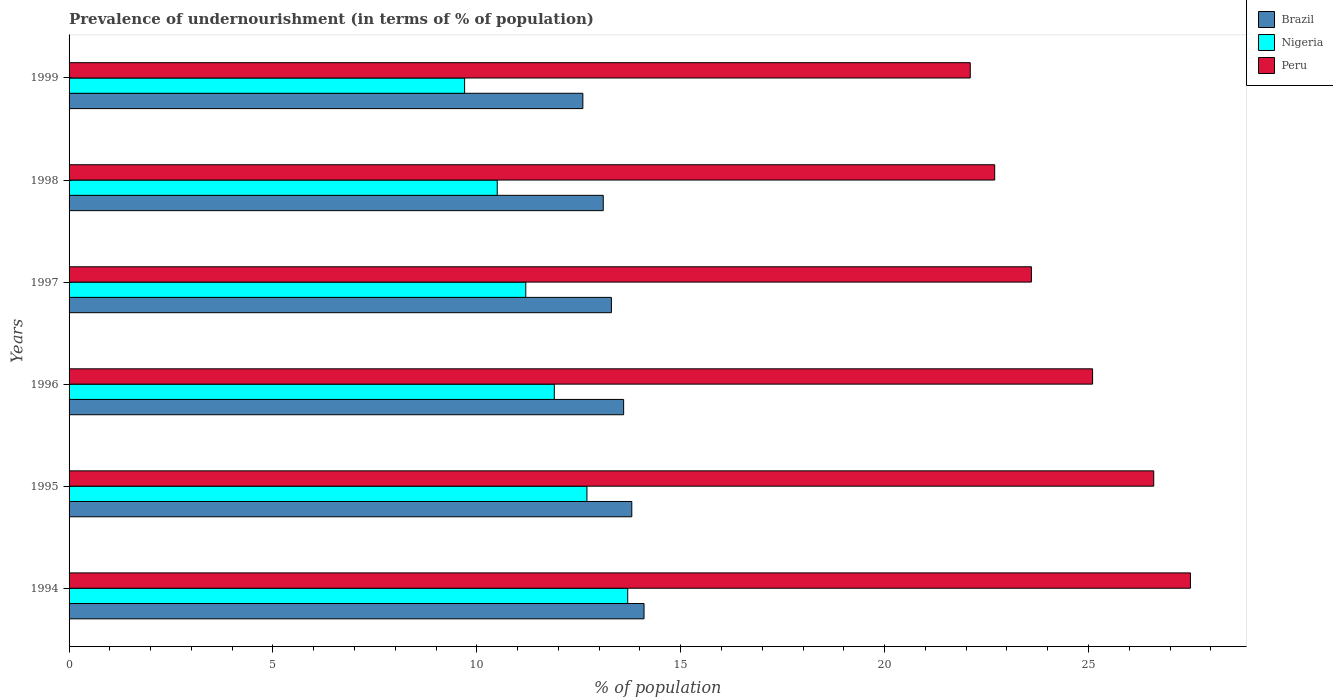How many bars are there on the 1st tick from the top?
Your answer should be very brief. 3. How many bars are there on the 4th tick from the bottom?
Your answer should be very brief. 3. In how many cases, is the number of bars for a given year not equal to the number of legend labels?
Make the answer very short. 0. What is the percentage of undernourished population in Peru in 1997?
Provide a short and direct response. 23.6. Across all years, what is the maximum percentage of undernourished population in Brazil?
Make the answer very short. 14.1. In which year was the percentage of undernourished population in Nigeria maximum?
Your response must be concise. 1994. What is the total percentage of undernourished population in Brazil in the graph?
Offer a very short reply. 80.5. What is the difference between the percentage of undernourished population in Peru in 1995 and that in 1996?
Give a very brief answer. 1.5. What is the difference between the percentage of undernourished population in Brazil in 1995 and the percentage of undernourished population in Nigeria in 1998?
Give a very brief answer. 3.3. What is the average percentage of undernourished population in Nigeria per year?
Your answer should be very brief. 11.62. In the year 1994, what is the difference between the percentage of undernourished population in Brazil and percentage of undernourished population in Nigeria?
Make the answer very short. 0.4. In how many years, is the percentage of undernourished population in Peru greater than 10 %?
Keep it short and to the point. 6. What is the ratio of the percentage of undernourished population in Peru in 1995 to that in 1998?
Provide a succinct answer. 1.17. Is the difference between the percentage of undernourished population in Brazil in 1995 and 1996 greater than the difference between the percentage of undernourished population in Nigeria in 1995 and 1996?
Ensure brevity in your answer.  No. What is the difference between the highest and the second highest percentage of undernourished population in Brazil?
Give a very brief answer. 0.3. Is the sum of the percentage of undernourished population in Nigeria in 1997 and 1998 greater than the maximum percentage of undernourished population in Peru across all years?
Provide a short and direct response. No. What does the 2nd bar from the top in 1999 represents?
Ensure brevity in your answer.  Nigeria. What does the 1st bar from the bottom in 1995 represents?
Provide a short and direct response. Brazil. How many bars are there?
Your answer should be compact. 18. Are all the bars in the graph horizontal?
Your response must be concise. Yes. What is the difference between two consecutive major ticks on the X-axis?
Offer a very short reply. 5. Does the graph contain any zero values?
Ensure brevity in your answer.  No. Does the graph contain grids?
Provide a short and direct response. No. How are the legend labels stacked?
Your answer should be very brief. Vertical. What is the title of the graph?
Your answer should be compact. Prevalence of undernourishment (in terms of % of population). Does "Nepal" appear as one of the legend labels in the graph?
Your answer should be very brief. No. What is the label or title of the X-axis?
Your answer should be very brief. % of population. What is the label or title of the Y-axis?
Make the answer very short. Years. What is the % of population of Brazil in 1994?
Your answer should be very brief. 14.1. What is the % of population in Nigeria in 1995?
Your response must be concise. 12.7. What is the % of population of Peru in 1995?
Your answer should be compact. 26.6. What is the % of population of Peru in 1996?
Your answer should be very brief. 25.1. What is the % of population of Brazil in 1997?
Offer a terse response. 13.3. What is the % of population of Nigeria in 1997?
Ensure brevity in your answer.  11.2. What is the % of population in Peru in 1997?
Ensure brevity in your answer.  23.6. What is the % of population of Peru in 1998?
Ensure brevity in your answer.  22.7. What is the % of population of Brazil in 1999?
Your answer should be very brief. 12.6. What is the % of population in Peru in 1999?
Your answer should be compact. 22.1. Across all years, what is the maximum % of population in Brazil?
Give a very brief answer. 14.1. Across all years, what is the maximum % of population in Peru?
Offer a terse response. 27.5. Across all years, what is the minimum % of population in Brazil?
Make the answer very short. 12.6. Across all years, what is the minimum % of population in Peru?
Your response must be concise. 22.1. What is the total % of population of Brazil in the graph?
Your response must be concise. 80.5. What is the total % of population in Nigeria in the graph?
Provide a succinct answer. 69.7. What is the total % of population in Peru in the graph?
Offer a very short reply. 147.6. What is the difference between the % of population of Nigeria in 1994 and that in 1996?
Make the answer very short. 1.8. What is the difference between the % of population of Peru in 1994 and that in 1996?
Ensure brevity in your answer.  2.4. What is the difference between the % of population of Brazil in 1994 and that in 1997?
Provide a short and direct response. 0.8. What is the difference between the % of population in Nigeria in 1994 and that in 1997?
Your answer should be compact. 2.5. What is the difference between the % of population of Peru in 1994 and that in 1997?
Your response must be concise. 3.9. What is the difference between the % of population of Brazil in 1994 and that in 1998?
Ensure brevity in your answer.  1. What is the difference between the % of population of Nigeria in 1994 and that in 1998?
Your response must be concise. 3.2. What is the difference between the % of population of Peru in 1994 and that in 1998?
Offer a terse response. 4.8. What is the difference between the % of population of Brazil in 1995 and that in 1997?
Offer a terse response. 0.5. What is the difference between the % of population of Peru in 1995 and that in 1997?
Ensure brevity in your answer.  3. What is the difference between the % of population of Brazil in 1995 and that in 1998?
Offer a very short reply. 0.7. What is the difference between the % of population in Peru in 1995 and that in 1998?
Provide a short and direct response. 3.9. What is the difference between the % of population in Brazil in 1995 and that in 1999?
Your response must be concise. 1.2. What is the difference between the % of population of Nigeria in 1995 and that in 1999?
Your response must be concise. 3. What is the difference between the % of population of Nigeria in 1996 and that in 1997?
Your response must be concise. 0.7. What is the difference between the % of population in Peru in 1996 and that in 1997?
Keep it short and to the point. 1.5. What is the difference between the % of population of Peru in 1996 and that in 1999?
Provide a succinct answer. 3. What is the difference between the % of population of Brazil in 1997 and that in 1998?
Provide a short and direct response. 0.2. What is the difference between the % of population of Peru in 1997 and that in 1998?
Make the answer very short. 0.9. What is the difference between the % of population in Brazil in 1997 and that in 1999?
Your answer should be compact. 0.7. What is the difference between the % of population in Peru in 1997 and that in 1999?
Give a very brief answer. 1.5. What is the difference between the % of population in Nigeria in 1998 and that in 1999?
Your answer should be very brief. 0.8. What is the difference between the % of population in Peru in 1998 and that in 1999?
Your answer should be very brief. 0.6. What is the difference between the % of population of Brazil in 1994 and the % of population of Peru in 1996?
Offer a terse response. -11. What is the difference between the % of population of Nigeria in 1994 and the % of population of Peru in 1996?
Your answer should be compact. -11.4. What is the difference between the % of population of Brazil in 1994 and the % of population of Nigeria in 1997?
Your answer should be compact. 2.9. What is the difference between the % of population of Brazil in 1994 and the % of population of Nigeria in 1998?
Make the answer very short. 3.6. What is the difference between the % of population of Nigeria in 1994 and the % of population of Peru in 1998?
Provide a succinct answer. -9. What is the difference between the % of population of Brazil in 1994 and the % of population of Nigeria in 1999?
Ensure brevity in your answer.  4.4. What is the difference between the % of population in Brazil in 1994 and the % of population in Peru in 1999?
Make the answer very short. -8. What is the difference between the % of population of Nigeria in 1994 and the % of population of Peru in 1999?
Keep it short and to the point. -8.4. What is the difference between the % of population in Brazil in 1995 and the % of population in Nigeria in 1996?
Offer a terse response. 1.9. What is the difference between the % of population in Brazil in 1995 and the % of population in Peru in 1997?
Give a very brief answer. -9.8. What is the difference between the % of population in Nigeria in 1995 and the % of population in Peru in 1997?
Offer a very short reply. -10.9. What is the difference between the % of population in Nigeria in 1995 and the % of population in Peru in 1998?
Offer a terse response. -10. What is the difference between the % of population of Brazil in 1995 and the % of population of Peru in 1999?
Make the answer very short. -8.3. What is the difference between the % of population in Brazil in 1996 and the % of population in Peru in 1997?
Your answer should be compact. -10. What is the difference between the % of population in Nigeria in 1996 and the % of population in Peru in 1997?
Provide a short and direct response. -11.7. What is the difference between the % of population in Brazil in 1997 and the % of population in Nigeria in 1998?
Ensure brevity in your answer.  2.8. What is the difference between the % of population of Brazil in 1998 and the % of population of Nigeria in 1999?
Provide a succinct answer. 3.4. What is the average % of population of Brazil per year?
Your answer should be compact. 13.42. What is the average % of population of Nigeria per year?
Your response must be concise. 11.62. What is the average % of population in Peru per year?
Your answer should be compact. 24.6. In the year 1994, what is the difference between the % of population of Brazil and % of population of Peru?
Provide a succinct answer. -13.4. In the year 1995, what is the difference between the % of population in Brazil and % of population in Peru?
Your answer should be very brief. -12.8. In the year 1996, what is the difference between the % of population of Brazil and % of population of Nigeria?
Offer a very short reply. 1.7. In the year 1996, what is the difference between the % of population of Nigeria and % of population of Peru?
Ensure brevity in your answer.  -13.2. In the year 1997, what is the difference between the % of population of Brazil and % of population of Peru?
Ensure brevity in your answer.  -10.3. In the year 1998, what is the difference between the % of population in Brazil and % of population in Nigeria?
Give a very brief answer. 2.6. In the year 1999, what is the difference between the % of population of Brazil and % of population of Nigeria?
Make the answer very short. 2.9. In the year 1999, what is the difference between the % of population in Brazil and % of population in Peru?
Give a very brief answer. -9.5. What is the ratio of the % of population of Brazil in 1994 to that in 1995?
Ensure brevity in your answer.  1.02. What is the ratio of the % of population in Nigeria in 1994 to that in 1995?
Your response must be concise. 1.08. What is the ratio of the % of population of Peru in 1994 to that in 1995?
Offer a very short reply. 1.03. What is the ratio of the % of population of Brazil in 1994 to that in 1996?
Make the answer very short. 1.04. What is the ratio of the % of population in Nigeria in 1994 to that in 1996?
Provide a succinct answer. 1.15. What is the ratio of the % of population of Peru in 1994 to that in 1996?
Ensure brevity in your answer.  1.1. What is the ratio of the % of population in Brazil in 1994 to that in 1997?
Make the answer very short. 1.06. What is the ratio of the % of population of Nigeria in 1994 to that in 1997?
Ensure brevity in your answer.  1.22. What is the ratio of the % of population of Peru in 1994 to that in 1997?
Your answer should be compact. 1.17. What is the ratio of the % of population in Brazil in 1994 to that in 1998?
Your response must be concise. 1.08. What is the ratio of the % of population of Nigeria in 1994 to that in 1998?
Your answer should be compact. 1.3. What is the ratio of the % of population in Peru in 1994 to that in 1998?
Your answer should be very brief. 1.21. What is the ratio of the % of population of Brazil in 1994 to that in 1999?
Offer a terse response. 1.12. What is the ratio of the % of population of Nigeria in 1994 to that in 1999?
Your answer should be very brief. 1.41. What is the ratio of the % of population of Peru in 1994 to that in 1999?
Your answer should be very brief. 1.24. What is the ratio of the % of population of Brazil in 1995 to that in 1996?
Your answer should be very brief. 1.01. What is the ratio of the % of population of Nigeria in 1995 to that in 1996?
Provide a short and direct response. 1.07. What is the ratio of the % of population in Peru in 1995 to that in 1996?
Keep it short and to the point. 1.06. What is the ratio of the % of population in Brazil in 1995 to that in 1997?
Your answer should be very brief. 1.04. What is the ratio of the % of population of Nigeria in 1995 to that in 1997?
Your answer should be compact. 1.13. What is the ratio of the % of population in Peru in 1995 to that in 1997?
Offer a terse response. 1.13. What is the ratio of the % of population in Brazil in 1995 to that in 1998?
Your answer should be very brief. 1.05. What is the ratio of the % of population in Nigeria in 1995 to that in 1998?
Offer a terse response. 1.21. What is the ratio of the % of population of Peru in 1995 to that in 1998?
Ensure brevity in your answer.  1.17. What is the ratio of the % of population of Brazil in 1995 to that in 1999?
Keep it short and to the point. 1.1. What is the ratio of the % of population in Nigeria in 1995 to that in 1999?
Your response must be concise. 1.31. What is the ratio of the % of population in Peru in 1995 to that in 1999?
Give a very brief answer. 1.2. What is the ratio of the % of population of Brazil in 1996 to that in 1997?
Give a very brief answer. 1.02. What is the ratio of the % of population of Nigeria in 1996 to that in 1997?
Provide a succinct answer. 1.06. What is the ratio of the % of population in Peru in 1996 to that in 1997?
Your answer should be very brief. 1.06. What is the ratio of the % of population in Brazil in 1996 to that in 1998?
Your answer should be very brief. 1.04. What is the ratio of the % of population in Nigeria in 1996 to that in 1998?
Provide a short and direct response. 1.13. What is the ratio of the % of population of Peru in 1996 to that in 1998?
Provide a succinct answer. 1.11. What is the ratio of the % of population in Brazil in 1996 to that in 1999?
Keep it short and to the point. 1.08. What is the ratio of the % of population in Nigeria in 1996 to that in 1999?
Offer a terse response. 1.23. What is the ratio of the % of population of Peru in 1996 to that in 1999?
Offer a terse response. 1.14. What is the ratio of the % of population in Brazil in 1997 to that in 1998?
Give a very brief answer. 1.02. What is the ratio of the % of population of Nigeria in 1997 to that in 1998?
Offer a terse response. 1.07. What is the ratio of the % of population in Peru in 1997 to that in 1998?
Your answer should be compact. 1.04. What is the ratio of the % of population in Brazil in 1997 to that in 1999?
Provide a short and direct response. 1.06. What is the ratio of the % of population in Nigeria in 1997 to that in 1999?
Your answer should be very brief. 1.15. What is the ratio of the % of population of Peru in 1997 to that in 1999?
Ensure brevity in your answer.  1.07. What is the ratio of the % of population in Brazil in 1998 to that in 1999?
Make the answer very short. 1.04. What is the ratio of the % of population of Nigeria in 1998 to that in 1999?
Your answer should be very brief. 1.08. What is the ratio of the % of population of Peru in 1998 to that in 1999?
Make the answer very short. 1.03. What is the difference between the highest and the lowest % of population of Brazil?
Ensure brevity in your answer.  1.5. What is the difference between the highest and the lowest % of population in Peru?
Offer a terse response. 5.4. 